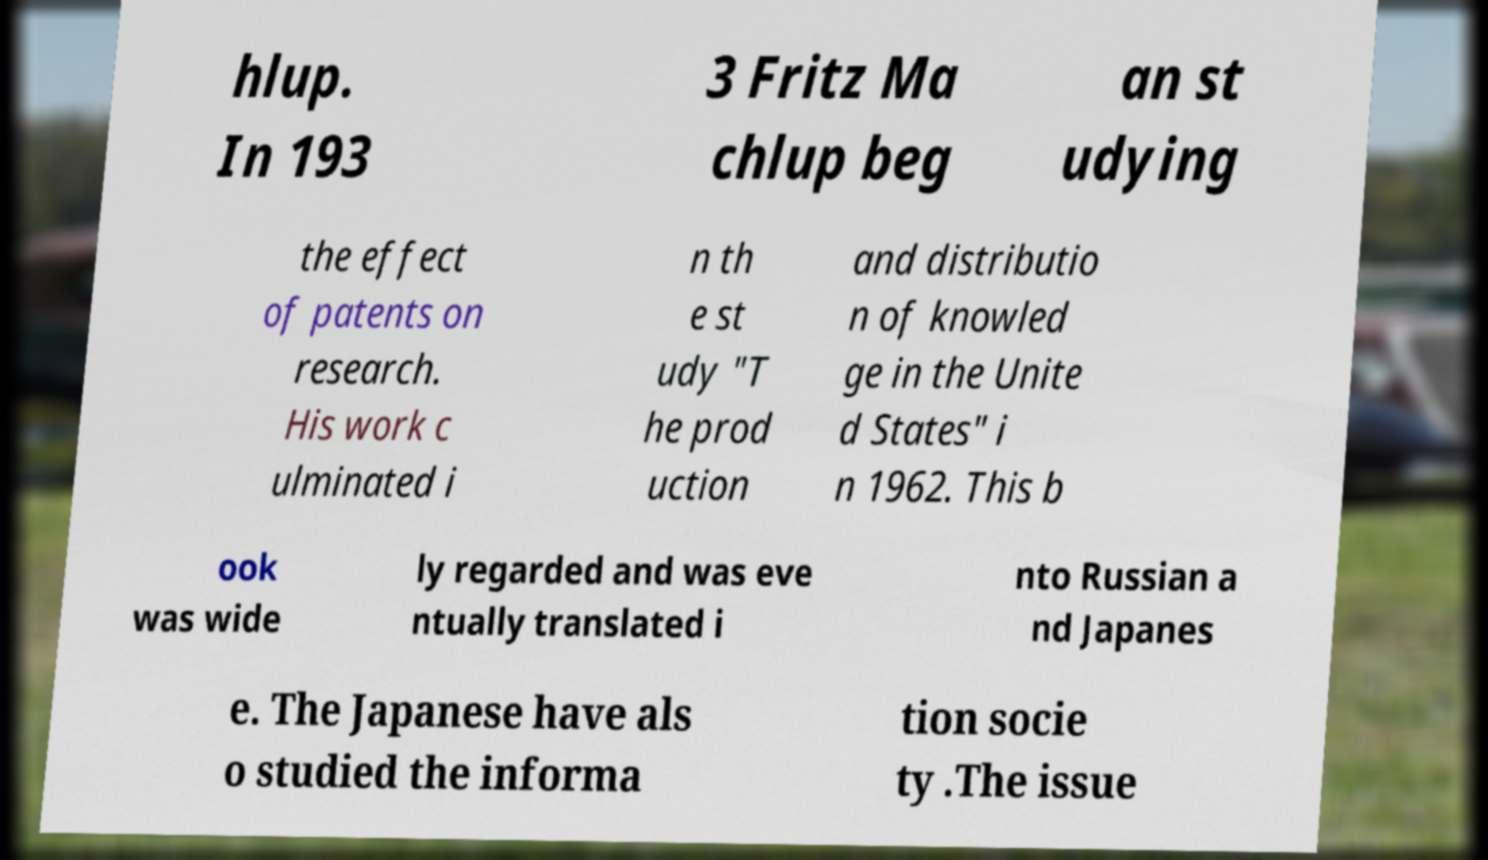Could you extract and type out the text from this image? hlup. In 193 3 Fritz Ma chlup beg an st udying the effect of patents on research. His work c ulminated i n th e st udy "T he prod uction and distributio n of knowled ge in the Unite d States" i n 1962. This b ook was wide ly regarded and was eve ntually translated i nto Russian a nd Japanes e. The Japanese have als o studied the informa tion socie ty .The issue 